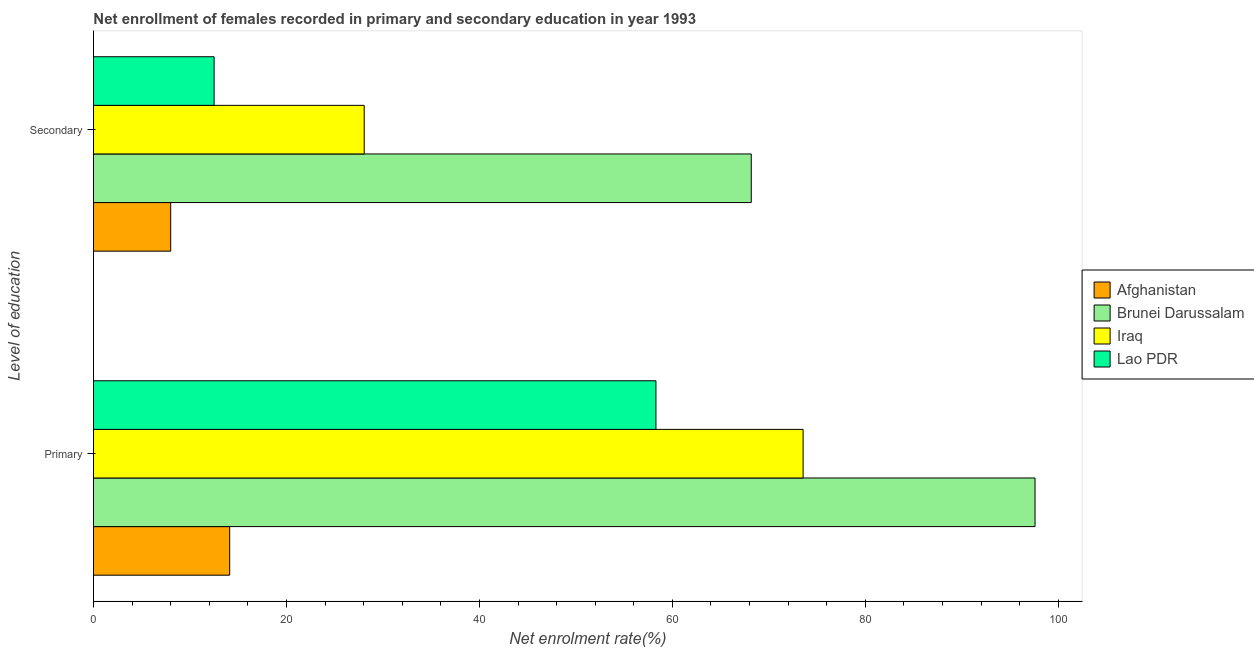How many groups of bars are there?
Ensure brevity in your answer.  2. Are the number of bars per tick equal to the number of legend labels?
Your answer should be very brief. Yes. Are the number of bars on each tick of the Y-axis equal?
Provide a succinct answer. Yes. How many bars are there on the 1st tick from the bottom?
Your response must be concise. 4. What is the label of the 2nd group of bars from the top?
Make the answer very short. Primary. What is the enrollment rate in primary education in Afghanistan?
Offer a very short reply. 14.12. Across all countries, what is the maximum enrollment rate in primary education?
Provide a short and direct response. 97.58. Across all countries, what is the minimum enrollment rate in primary education?
Offer a terse response. 14.12. In which country was the enrollment rate in secondary education maximum?
Your answer should be very brief. Brunei Darussalam. In which country was the enrollment rate in primary education minimum?
Your answer should be very brief. Afghanistan. What is the total enrollment rate in primary education in the graph?
Provide a succinct answer. 243.54. What is the difference between the enrollment rate in primary education in Afghanistan and that in Brunei Darussalam?
Give a very brief answer. -83.47. What is the difference between the enrollment rate in primary education in Iraq and the enrollment rate in secondary education in Afghanistan?
Make the answer very short. 65.55. What is the average enrollment rate in primary education per country?
Your answer should be very brief. 60.89. What is the difference between the enrollment rate in primary education and enrollment rate in secondary education in Brunei Darussalam?
Offer a terse response. 29.41. In how many countries, is the enrollment rate in secondary education greater than 68 %?
Make the answer very short. 1. What is the ratio of the enrollment rate in secondary education in Afghanistan to that in Iraq?
Give a very brief answer. 0.29. What does the 2nd bar from the top in Secondary represents?
Give a very brief answer. Iraq. What does the 2nd bar from the bottom in Primary represents?
Your answer should be compact. Brunei Darussalam. Are all the bars in the graph horizontal?
Provide a succinct answer. Yes. Are the values on the major ticks of X-axis written in scientific E-notation?
Make the answer very short. No. Does the graph contain any zero values?
Offer a terse response. No. Does the graph contain grids?
Ensure brevity in your answer.  No. Where does the legend appear in the graph?
Your answer should be very brief. Center right. How many legend labels are there?
Your response must be concise. 4. How are the legend labels stacked?
Give a very brief answer. Vertical. What is the title of the graph?
Keep it short and to the point. Net enrollment of females recorded in primary and secondary education in year 1993. What is the label or title of the X-axis?
Give a very brief answer. Net enrolment rate(%). What is the label or title of the Y-axis?
Your answer should be compact. Level of education. What is the Net enrolment rate(%) in Afghanistan in Primary?
Make the answer very short. 14.12. What is the Net enrolment rate(%) of Brunei Darussalam in Primary?
Provide a short and direct response. 97.58. What is the Net enrolment rate(%) in Iraq in Primary?
Your response must be concise. 73.55. What is the Net enrolment rate(%) in Lao PDR in Primary?
Your answer should be compact. 58.3. What is the Net enrolment rate(%) of Afghanistan in Secondary?
Offer a terse response. 8. What is the Net enrolment rate(%) of Brunei Darussalam in Secondary?
Your response must be concise. 68.17. What is the Net enrolment rate(%) of Iraq in Secondary?
Ensure brevity in your answer.  28.06. What is the Net enrolment rate(%) in Lao PDR in Secondary?
Offer a very short reply. 12.5. Across all Level of education, what is the maximum Net enrolment rate(%) of Afghanistan?
Keep it short and to the point. 14.12. Across all Level of education, what is the maximum Net enrolment rate(%) of Brunei Darussalam?
Offer a terse response. 97.58. Across all Level of education, what is the maximum Net enrolment rate(%) of Iraq?
Make the answer very short. 73.55. Across all Level of education, what is the maximum Net enrolment rate(%) of Lao PDR?
Your answer should be compact. 58.3. Across all Level of education, what is the minimum Net enrolment rate(%) of Afghanistan?
Your answer should be very brief. 8. Across all Level of education, what is the minimum Net enrolment rate(%) of Brunei Darussalam?
Offer a terse response. 68.17. Across all Level of education, what is the minimum Net enrolment rate(%) in Iraq?
Your response must be concise. 28.06. Across all Level of education, what is the minimum Net enrolment rate(%) of Lao PDR?
Your answer should be compact. 12.5. What is the total Net enrolment rate(%) of Afghanistan in the graph?
Provide a succinct answer. 22.12. What is the total Net enrolment rate(%) in Brunei Darussalam in the graph?
Your answer should be compact. 165.75. What is the total Net enrolment rate(%) in Iraq in the graph?
Your answer should be very brief. 101.61. What is the total Net enrolment rate(%) of Lao PDR in the graph?
Provide a short and direct response. 70.8. What is the difference between the Net enrolment rate(%) of Afghanistan in Primary and that in Secondary?
Offer a very short reply. 6.12. What is the difference between the Net enrolment rate(%) in Brunei Darussalam in Primary and that in Secondary?
Ensure brevity in your answer.  29.41. What is the difference between the Net enrolment rate(%) of Iraq in Primary and that in Secondary?
Your answer should be very brief. 45.49. What is the difference between the Net enrolment rate(%) of Lao PDR in Primary and that in Secondary?
Your response must be concise. 45.79. What is the difference between the Net enrolment rate(%) in Afghanistan in Primary and the Net enrolment rate(%) in Brunei Darussalam in Secondary?
Your answer should be compact. -54.05. What is the difference between the Net enrolment rate(%) of Afghanistan in Primary and the Net enrolment rate(%) of Iraq in Secondary?
Your response must be concise. -13.94. What is the difference between the Net enrolment rate(%) in Afghanistan in Primary and the Net enrolment rate(%) in Lao PDR in Secondary?
Offer a terse response. 1.62. What is the difference between the Net enrolment rate(%) in Brunei Darussalam in Primary and the Net enrolment rate(%) in Iraq in Secondary?
Provide a short and direct response. 69.52. What is the difference between the Net enrolment rate(%) in Brunei Darussalam in Primary and the Net enrolment rate(%) in Lao PDR in Secondary?
Provide a short and direct response. 85.08. What is the difference between the Net enrolment rate(%) in Iraq in Primary and the Net enrolment rate(%) in Lao PDR in Secondary?
Offer a terse response. 61.05. What is the average Net enrolment rate(%) of Afghanistan per Level of education?
Keep it short and to the point. 11.06. What is the average Net enrolment rate(%) in Brunei Darussalam per Level of education?
Make the answer very short. 82.88. What is the average Net enrolment rate(%) in Iraq per Level of education?
Ensure brevity in your answer.  50.8. What is the average Net enrolment rate(%) in Lao PDR per Level of education?
Your response must be concise. 35.4. What is the difference between the Net enrolment rate(%) of Afghanistan and Net enrolment rate(%) of Brunei Darussalam in Primary?
Your answer should be very brief. -83.47. What is the difference between the Net enrolment rate(%) in Afghanistan and Net enrolment rate(%) in Iraq in Primary?
Your response must be concise. -59.43. What is the difference between the Net enrolment rate(%) in Afghanistan and Net enrolment rate(%) in Lao PDR in Primary?
Keep it short and to the point. -44.18. What is the difference between the Net enrolment rate(%) of Brunei Darussalam and Net enrolment rate(%) of Iraq in Primary?
Your answer should be very brief. 24.04. What is the difference between the Net enrolment rate(%) in Brunei Darussalam and Net enrolment rate(%) in Lao PDR in Primary?
Your answer should be very brief. 39.29. What is the difference between the Net enrolment rate(%) in Iraq and Net enrolment rate(%) in Lao PDR in Primary?
Give a very brief answer. 15.25. What is the difference between the Net enrolment rate(%) in Afghanistan and Net enrolment rate(%) in Brunei Darussalam in Secondary?
Keep it short and to the point. -60.17. What is the difference between the Net enrolment rate(%) in Afghanistan and Net enrolment rate(%) in Iraq in Secondary?
Offer a very short reply. -20.06. What is the difference between the Net enrolment rate(%) of Afghanistan and Net enrolment rate(%) of Lao PDR in Secondary?
Offer a terse response. -4.5. What is the difference between the Net enrolment rate(%) in Brunei Darussalam and Net enrolment rate(%) in Iraq in Secondary?
Your answer should be very brief. 40.11. What is the difference between the Net enrolment rate(%) of Brunei Darussalam and Net enrolment rate(%) of Lao PDR in Secondary?
Give a very brief answer. 55.67. What is the difference between the Net enrolment rate(%) of Iraq and Net enrolment rate(%) of Lao PDR in Secondary?
Give a very brief answer. 15.56. What is the ratio of the Net enrolment rate(%) of Afghanistan in Primary to that in Secondary?
Provide a short and direct response. 1.76. What is the ratio of the Net enrolment rate(%) of Brunei Darussalam in Primary to that in Secondary?
Your response must be concise. 1.43. What is the ratio of the Net enrolment rate(%) in Iraq in Primary to that in Secondary?
Keep it short and to the point. 2.62. What is the ratio of the Net enrolment rate(%) in Lao PDR in Primary to that in Secondary?
Make the answer very short. 4.66. What is the difference between the highest and the second highest Net enrolment rate(%) of Afghanistan?
Your answer should be compact. 6.12. What is the difference between the highest and the second highest Net enrolment rate(%) in Brunei Darussalam?
Your answer should be very brief. 29.41. What is the difference between the highest and the second highest Net enrolment rate(%) in Iraq?
Offer a very short reply. 45.49. What is the difference between the highest and the second highest Net enrolment rate(%) of Lao PDR?
Offer a terse response. 45.79. What is the difference between the highest and the lowest Net enrolment rate(%) in Afghanistan?
Provide a succinct answer. 6.12. What is the difference between the highest and the lowest Net enrolment rate(%) in Brunei Darussalam?
Give a very brief answer. 29.41. What is the difference between the highest and the lowest Net enrolment rate(%) of Iraq?
Your answer should be compact. 45.49. What is the difference between the highest and the lowest Net enrolment rate(%) in Lao PDR?
Make the answer very short. 45.79. 